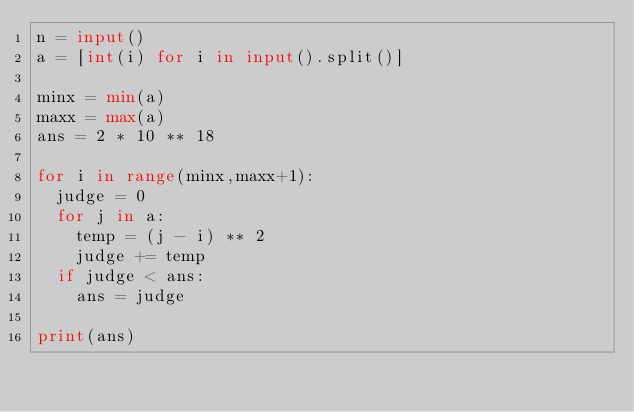Convert code to text. <code><loc_0><loc_0><loc_500><loc_500><_Python_>n = input()
a = [int(i) for i in input().split()]

minx = min(a)
maxx = max(a)
ans = 2 * 10 ** 18

for i in range(minx,maxx+1):
  judge = 0
  for j in a:
    temp = (j - i) ** 2
    judge += temp
  if judge < ans:
    ans = judge

print(ans)
</code> 